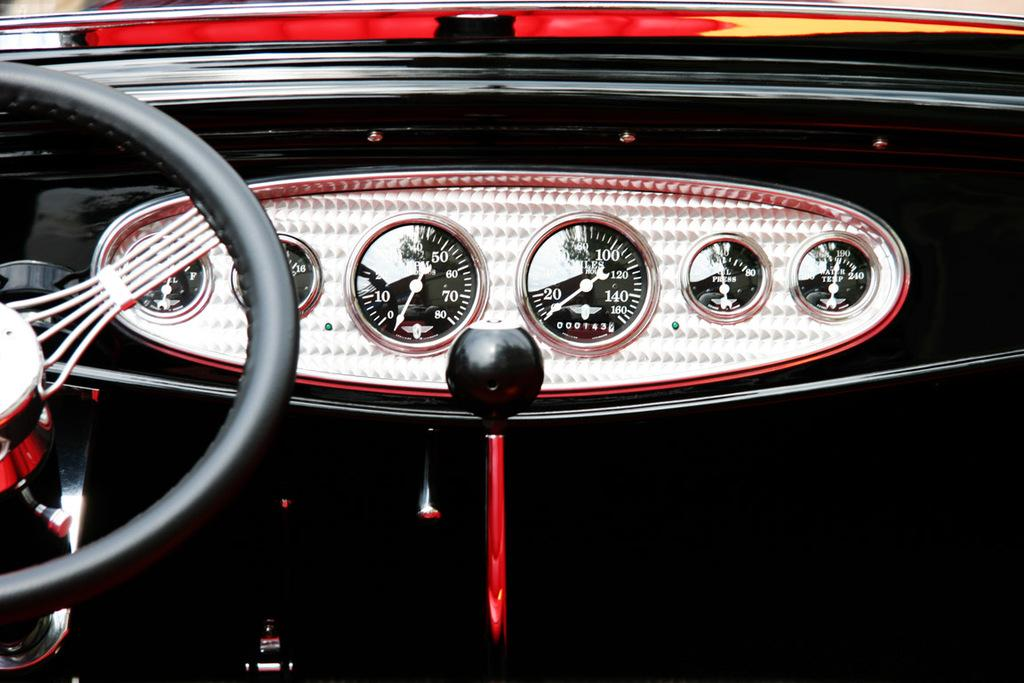What is the setting of the image? The image is taken inside a vehicle. What instrument is visible in the middle of the image? There is a speedometer in the middle of the image. What is located on the left side of the image? There is a steering wheel on the left side of the image. What type of trousers can be seen hanging from the speedometer in the image? There are no trousers present in the image, and they are not hanging from the speedometer. 